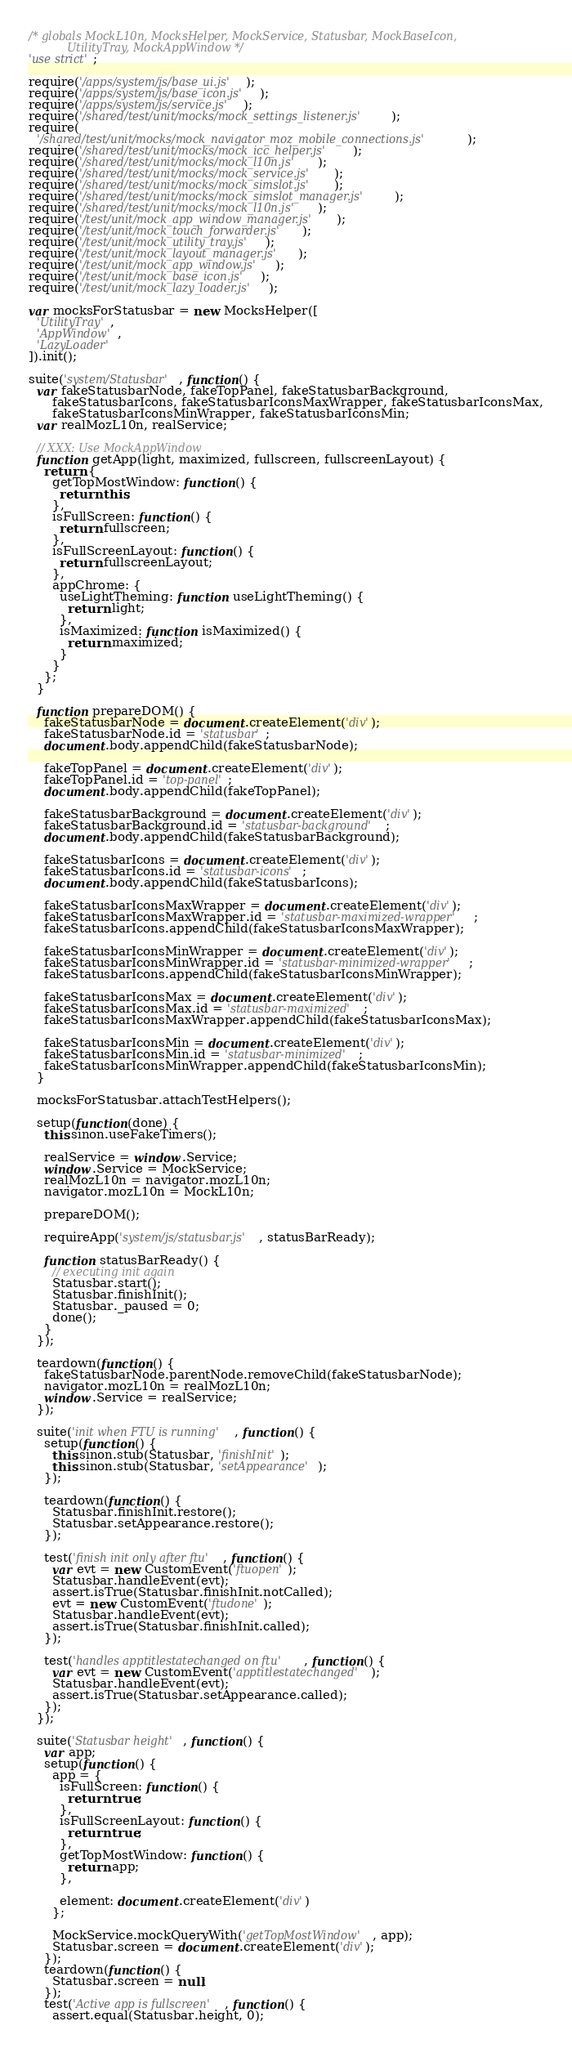<code> <loc_0><loc_0><loc_500><loc_500><_JavaScript_>/* globals MockL10n, MocksHelper, MockService, Statusbar, MockBaseIcon,
           UtilityTray, MockAppWindow */
'use strict';

require('/apps/system/js/base_ui.js');
require('/apps/system/js/base_icon.js');
require('/apps/system/js/service.js');
require('/shared/test/unit/mocks/mock_settings_listener.js');
require(
  '/shared/test/unit/mocks/mock_navigator_moz_mobile_connections.js');
require('/shared/test/unit/mocks/mock_icc_helper.js');
require('/shared/test/unit/mocks/mock_l10n.js');
require('/shared/test/unit/mocks/mock_service.js');
require('/shared/test/unit/mocks/mock_simslot.js');
require('/shared/test/unit/mocks/mock_simslot_manager.js');
require('/shared/test/unit/mocks/mock_l10n.js');
require('/test/unit/mock_app_window_manager.js');
require('/test/unit/mock_touch_forwarder.js');
require('/test/unit/mock_utility_tray.js');
require('/test/unit/mock_layout_manager.js');
require('/test/unit/mock_app_window.js');
require('/test/unit/mock_base_icon.js');
require('/test/unit/mock_lazy_loader.js');

var mocksForStatusbar = new MocksHelper([
  'UtilityTray',
  'AppWindow',
  'LazyLoader'
]).init();

suite('system/Statusbar', function() {
  var fakeStatusbarNode, fakeTopPanel, fakeStatusbarBackground,
      fakeStatusbarIcons, fakeStatusbarIconsMaxWrapper, fakeStatusbarIconsMax,
      fakeStatusbarIconsMinWrapper, fakeStatusbarIconsMin;
  var realMozL10n, realService;

  // XXX: Use MockAppWindow
  function getApp(light, maximized, fullscreen, fullscreenLayout) {
    return {
      getTopMostWindow: function() {
        return this;
      },
      isFullScreen: function() {
        return fullscreen;
      },
      isFullScreenLayout: function() {
        return fullscreenLayout;
      },
      appChrome: {
        useLightTheming: function useLightTheming() {
          return light;
        },
        isMaximized: function isMaximized() {
          return maximized;
        }
      }
    };
  }

  function prepareDOM() {
    fakeStatusbarNode = document.createElement('div');
    fakeStatusbarNode.id = 'statusbar';
    document.body.appendChild(fakeStatusbarNode);

    fakeTopPanel = document.createElement('div');
    fakeTopPanel.id = 'top-panel';
    document.body.appendChild(fakeTopPanel);

    fakeStatusbarBackground = document.createElement('div');
    fakeStatusbarBackground.id = 'statusbar-background';
    document.body.appendChild(fakeStatusbarBackground);

    fakeStatusbarIcons = document.createElement('div');
    fakeStatusbarIcons.id = 'statusbar-icons';
    document.body.appendChild(fakeStatusbarIcons);

    fakeStatusbarIconsMaxWrapper = document.createElement('div');
    fakeStatusbarIconsMaxWrapper.id = 'statusbar-maximized-wrapper';
    fakeStatusbarIcons.appendChild(fakeStatusbarIconsMaxWrapper);

    fakeStatusbarIconsMinWrapper = document.createElement('div');
    fakeStatusbarIconsMinWrapper.id = 'statusbar-minimized-wrapper';
    fakeStatusbarIcons.appendChild(fakeStatusbarIconsMinWrapper);

    fakeStatusbarIconsMax = document.createElement('div');
    fakeStatusbarIconsMax.id = 'statusbar-maximized';
    fakeStatusbarIconsMaxWrapper.appendChild(fakeStatusbarIconsMax);

    fakeStatusbarIconsMin = document.createElement('div');
    fakeStatusbarIconsMin.id = 'statusbar-minimized';
    fakeStatusbarIconsMinWrapper.appendChild(fakeStatusbarIconsMin);
  }

  mocksForStatusbar.attachTestHelpers();

  setup(function(done) {
    this.sinon.useFakeTimers();

    realService = window.Service;
    window.Service = MockService;
    realMozL10n = navigator.mozL10n;
    navigator.mozL10n = MockL10n;

    prepareDOM();

    requireApp('system/js/statusbar.js', statusBarReady);

    function statusBarReady() {
      // executing init again
      Statusbar.start();
      Statusbar.finishInit();
      Statusbar._paused = 0;
      done();
    }
  });

  teardown(function() {
    fakeStatusbarNode.parentNode.removeChild(fakeStatusbarNode);
    navigator.mozL10n = realMozL10n;
    window.Service = realService;
  });

  suite('init when FTU is running', function() {
    setup(function() {
      this.sinon.stub(Statusbar, 'finishInit');
      this.sinon.stub(Statusbar, 'setAppearance');
    });

    teardown(function() {
      Statusbar.finishInit.restore();
      Statusbar.setAppearance.restore();
    });

    test('finish init only after ftu', function() {
      var evt = new CustomEvent('ftuopen');
      Statusbar.handleEvent(evt);
      assert.isTrue(Statusbar.finishInit.notCalled);
      evt = new CustomEvent('ftudone');
      Statusbar.handleEvent(evt);
      assert.isTrue(Statusbar.finishInit.called);
    });

    test('handles apptitlestatechanged on ftu', function() {
      var evt = new CustomEvent('apptitlestatechanged');
      Statusbar.handleEvent(evt);
      assert.isTrue(Statusbar.setAppearance.called);
    });
  });

  suite('Statusbar height', function() {
    var app;
    setup(function() {
      app = {
        isFullScreen: function() {
          return true;
        },
        isFullScreenLayout: function() {
          return true;
        },
        getTopMostWindow: function() {
          return app;
        },

        element: document.createElement('div')
      };

      MockService.mockQueryWith('getTopMostWindow', app);
      Statusbar.screen = document.createElement('div');
    });
    teardown(function() {
      Statusbar.screen = null;
    });
    test('Active app is fullscreen', function() {
      assert.equal(Statusbar.height, 0);</code> 